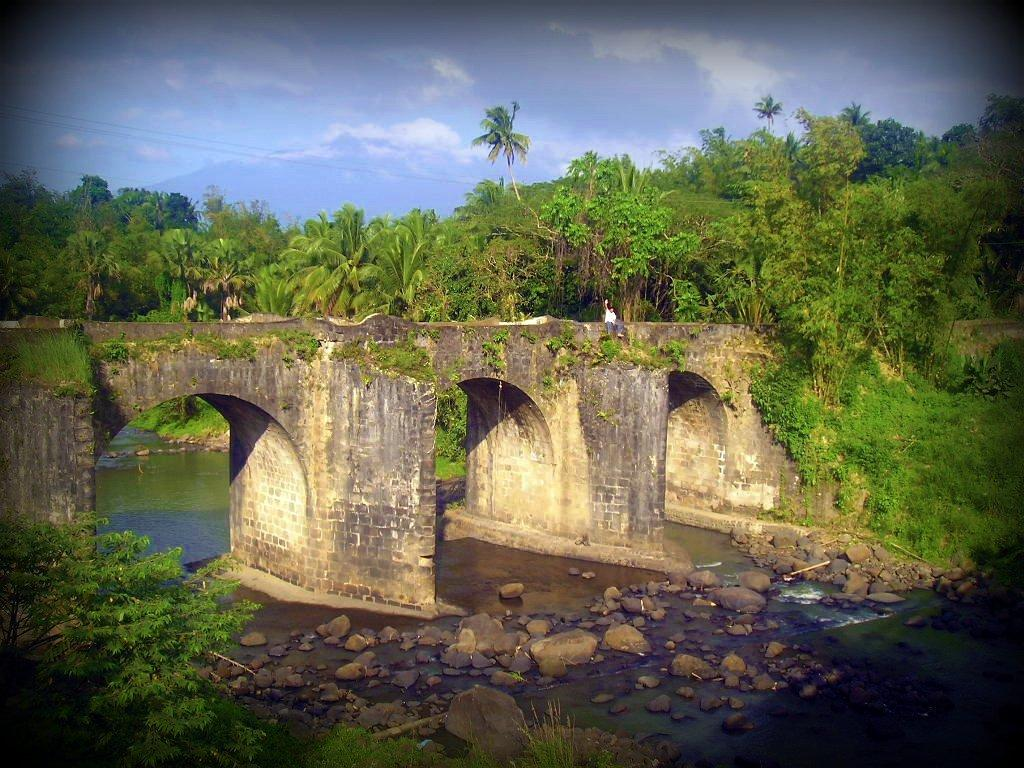What type of natural elements can be seen in the image? There are trees and water visible in the image. What man-made structure is present in the image? There is a bridge in the image. What type of terrain is depicted in the image? There are stones in the image, suggesting a rocky or uneven surface. What is the color of the sky in the image? The sky is in white and blue color. Can you describe the person in the image? There is a person in the image, but no specific details about their appearance or actions are provided. What type of fowl can be seen flying over the bridge in the image? There is no fowl visible in the image; only trees, water, stones, a bridge, and a person are present. Can you tell me how the guide is assisting the person in the image? There is no guide or indication of assistance in the image; only a person is present. 